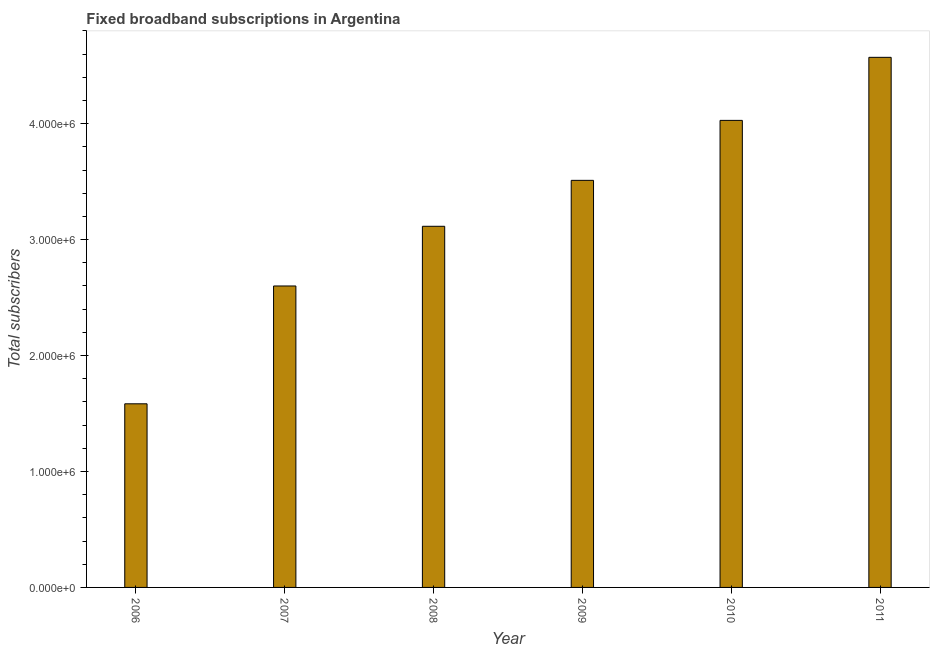Does the graph contain grids?
Offer a terse response. No. What is the title of the graph?
Make the answer very short. Fixed broadband subscriptions in Argentina. What is the label or title of the Y-axis?
Your answer should be compact. Total subscribers. What is the total number of fixed broadband subscriptions in 2010?
Keep it short and to the point. 4.03e+06. Across all years, what is the maximum total number of fixed broadband subscriptions?
Your response must be concise. 4.57e+06. Across all years, what is the minimum total number of fixed broadband subscriptions?
Provide a short and direct response. 1.58e+06. In which year was the total number of fixed broadband subscriptions maximum?
Give a very brief answer. 2011. What is the sum of the total number of fixed broadband subscriptions?
Provide a succinct answer. 1.94e+07. What is the difference between the total number of fixed broadband subscriptions in 2007 and 2009?
Offer a very short reply. -9.11e+05. What is the average total number of fixed broadband subscriptions per year?
Offer a very short reply. 3.23e+06. What is the median total number of fixed broadband subscriptions?
Offer a very short reply. 3.31e+06. In how many years, is the total number of fixed broadband subscriptions greater than 200000 ?
Offer a very short reply. 6. Do a majority of the years between 2008 and 2010 (inclusive) have total number of fixed broadband subscriptions greater than 4400000 ?
Your answer should be compact. No. What is the ratio of the total number of fixed broadband subscriptions in 2009 to that in 2010?
Ensure brevity in your answer.  0.87. Is the total number of fixed broadband subscriptions in 2007 less than that in 2010?
Your answer should be very brief. Yes. Is the difference between the total number of fixed broadband subscriptions in 2008 and 2011 greater than the difference between any two years?
Offer a terse response. No. What is the difference between the highest and the second highest total number of fixed broadband subscriptions?
Ensure brevity in your answer.  5.44e+05. Is the sum of the total number of fixed broadband subscriptions in 2006 and 2011 greater than the maximum total number of fixed broadband subscriptions across all years?
Keep it short and to the point. Yes. What is the difference between the highest and the lowest total number of fixed broadband subscriptions?
Your answer should be very brief. 2.99e+06. Are all the bars in the graph horizontal?
Your answer should be very brief. No. What is the Total subscribers in 2006?
Provide a succinct answer. 1.58e+06. What is the Total subscribers in 2007?
Your response must be concise. 2.60e+06. What is the Total subscribers in 2008?
Ensure brevity in your answer.  3.11e+06. What is the Total subscribers of 2009?
Your response must be concise. 3.51e+06. What is the Total subscribers in 2010?
Offer a very short reply. 4.03e+06. What is the Total subscribers of 2011?
Provide a short and direct response. 4.57e+06. What is the difference between the Total subscribers in 2006 and 2007?
Your answer should be very brief. -1.02e+06. What is the difference between the Total subscribers in 2006 and 2008?
Provide a short and direct response. -1.53e+06. What is the difference between the Total subscribers in 2006 and 2009?
Provide a succinct answer. -1.93e+06. What is the difference between the Total subscribers in 2006 and 2010?
Keep it short and to the point. -2.44e+06. What is the difference between the Total subscribers in 2006 and 2011?
Provide a succinct answer. -2.99e+06. What is the difference between the Total subscribers in 2007 and 2008?
Give a very brief answer. -5.15e+05. What is the difference between the Total subscribers in 2007 and 2009?
Your answer should be very brief. -9.11e+05. What is the difference between the Total subscribers in 2007 and 2010?
Ensure brevity in your answer.  -1.43e+06. What is the difference between the Total subscribers in 2007 and 2011?
Make the answer very short. -1.97e+06. What is the difference between the Total subscribers in 2008 and 2009?
Make the answer very short. -3.96e+05. What is the difference between the Total subscribers in 2008 and 2010?
Keep it short and to the point. -9.13e+05. What is the difference between the Total subscribers in 2008 and 2011?
Provide a succinct answer. -1.46e+06. What is the difference between the Total subscribers in 2009 and 2010?
Provide a short and direct response. -5.17e+05. What is the difference between the Total subscribers in 2009 and 2011?
Keep it short and to the point. -1.06e+06. What is the difference between the Total subscribers in 2010 and 2011?
Provide a short and direct response. -5.44e+05. What is the ratio of the Total subscribers in 2006 to that in 2007?
Keep it short and to the point. 0.61. What is the ratio of the Total subscribers in 2006 to that in 2008?
Offer a very short reply. 0.51. What is the ratio of the Total subscribers in 2006 to that in 2009?
Offer a terse response. 0.45. What is the ratio of the Total subscribers in 2006 to that in 2010?
Offer a terse response. 0.39. What is the ratio of the Total subscribers in 2006 to that in 2011?
Ensure brevity in your answer.  0.35. What is the ratio of the Total subscribers in 2007 to that in 2008?
Your response must be concise. 0.83. What is the ratio of the Total subscribers in 2007 to that in 2009?
Offer a terse response. 0.74. What is the ratio of the Total subscribers in 2007 to that in 2010?
Give a very brief answer. 0.65. What is the ratio of the Total subscribers in 2007 to that in 2011?
Make the answer very short. 0.57. What is the ratio of the Total subscribers in 2008 to that in 2009?
Provide a succinct answer. 0.89. What is the ratio of the Total subscribers in 2008 to that in 2010?
Make the answer very short. 0.77. What is the ratio of the Total subscribers in 2008 to that in 2011?
Offer a terse response. 0.68. What is the ratio of the Total subscribers in 2009 to that in 2010?
Offer a terse response. 0.87. What is the ratio of the Total subscribers in 2009 to that in 2011?
Offer a very short reply. 0.77. What is the ratio of the Total subscribers in 2010 to that in 2011?
Offer a terse response. 0.88. 